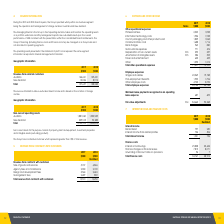According to National Storage Reit's financial document, How many business segments were present in 2019 and 2018? According to the financial document, one. The relevant text states: "financial years, the Group operated wholly within one business segment being the operation and management of storage centres in Australia and New Zealand..." Also, How are the Group's financing managed? on a Group basis and not allocated to operating segments.. The document states: "ding finance costs and finance income) are managed on a Group basis and not allocated to operating segments. The operating results presented in the st..." Also, What were the revenues from Australia and New Zealand in 2019 respectively? The document shows two values: 144,621 and 13,036 (in thousands). From the document: "Australia 144,621 129,431 New Zealand 13,036 8,912..." Also, can you calculate: What is the change in the revenue from Australia from 2018 to 2019? Based on the calculation: 144,621 - 129,431, the result is 15190 (in thousands). This is based on the information: "Australia 144,621 129,431 Australia 144,621 129,431..." The key data points involved are: 129,431, 144,621. Also, can you calculate: What is the average revenue from New Zealand for 2018 and 2019? To answer this question, I need to perform calculations using the financial data. The calculation is: (13,036 + 8,912) / 2, which equals 10974 (in thousands). This is based on the information: "New Zealand 13,036 8,912 New Zealand 13,036 8,912..." The key data points involved are: 13,036, 8,912. Additionally, In which year was revenue from New Zealand under 10,000 thousands? According to the financial document, 2018. The relevant text states: "2019 2018..." 